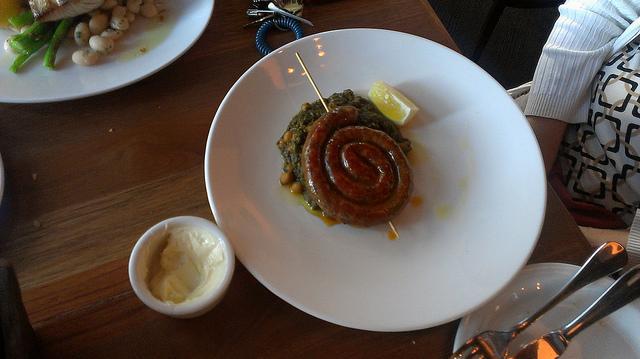What condiment is in the small white container next to the dish? Please explain your reasoning. butter. This is a yellowish fatty spread 